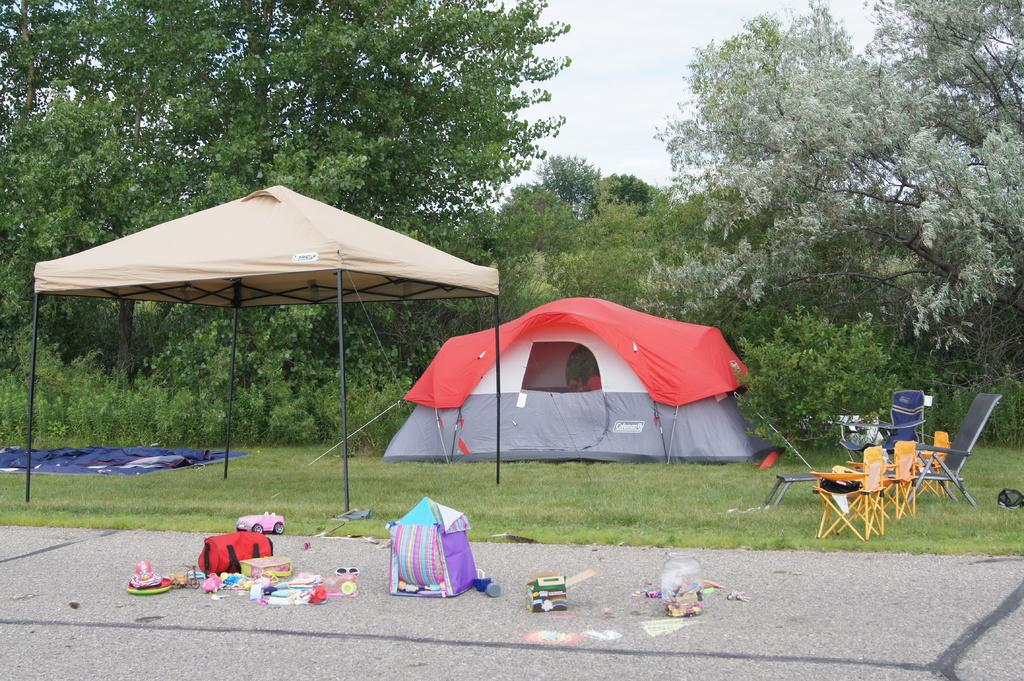What type of temporary shelters can be seen in the image? There are tents in the image. What type of seating is available in the image? There are chairs in the image. Where are objects placed in the image? Objects are placed on the grass and the pavement in the image. What can be seen in the background of the image? There are trees and the sky visible in the background of the image. What type of jar is placed on the garden in the image? There is no jar or garden present in the image. How many cars can be seen driving on the pavement in the image? There are no cars visible in the image; it only features tents, chairs, objects on the grass and pavement, trees, and the sky in the background. 